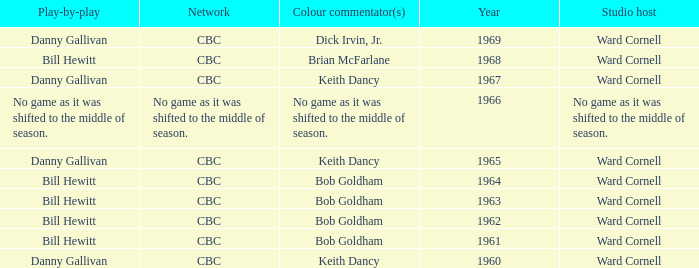Were the color commentators who worked with Bill Hewitt doing the play-by-play? Brian McFarlane, Bob Goldham, Bob Goldham, Bob Goldham, Bob Goldham. 